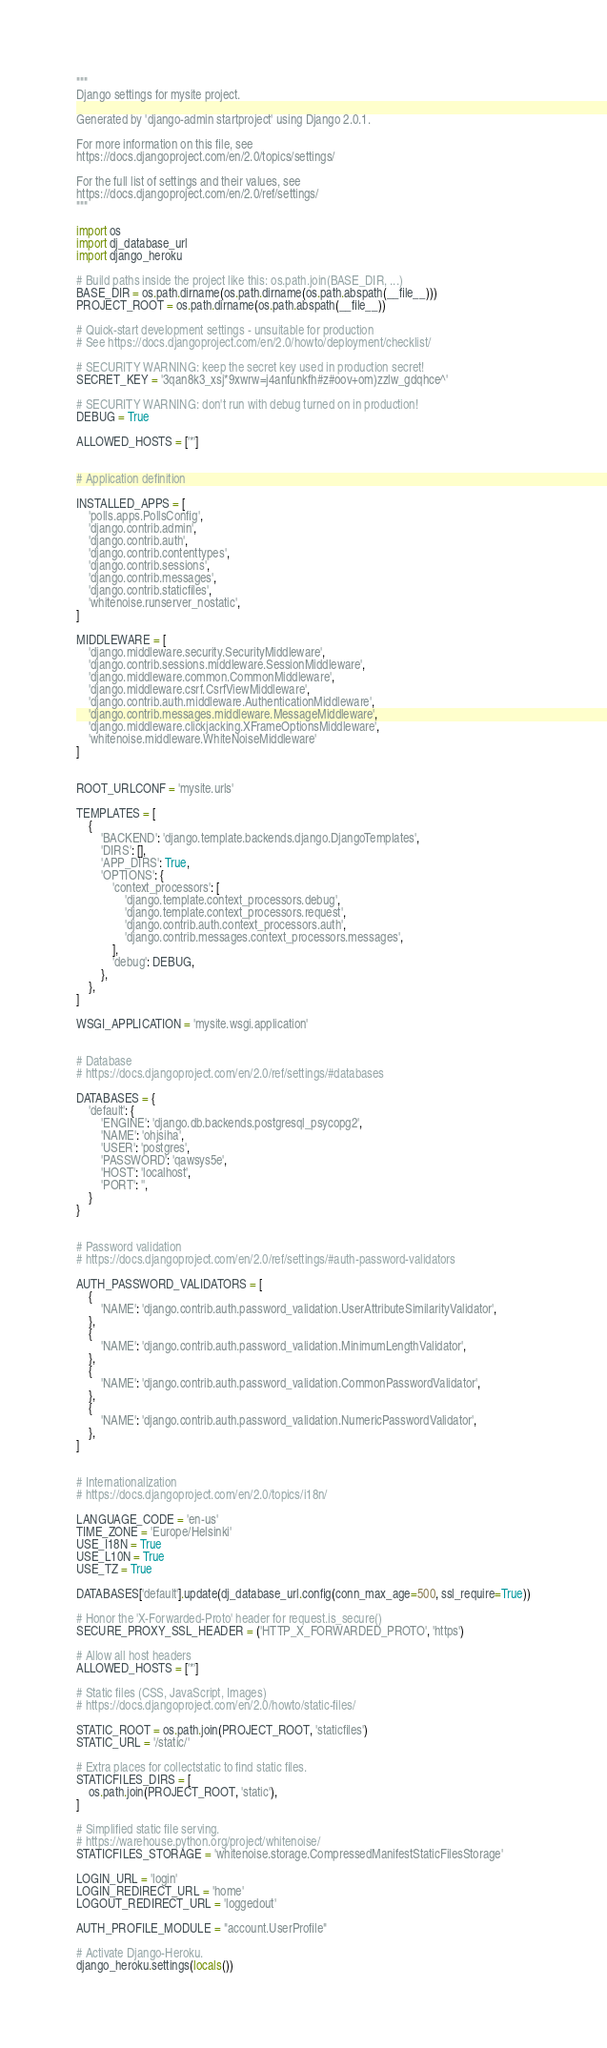Convert code to text. <code><loc_0><loc_0><loc_500><loc_500><_Python_>"""
Django settings for mysite project.

Generated by 'django-admin startproject' using Django 2.0.1.

For more information on this file, see
https://docs.djangoproject.com/en/2.0/topics/settings/

For the full list of settings and their values, see
https://docs.djangoproject.com/en/2.0/ref/settings/
"""

import os
import dj_database_url
import django_heroku

# Build paths inside the project like this: os.path.join(BASE_DIR, ...)
BASE_DIR = os.path.dirname(os.path.dirname(os.path.abspath(__file__)))
PROJECT_ROOT = os.path.dirname(os.path.abspath(__file__))

# Quick-start development settings - unsuitable for production
# See https://docs.djangoproject.com/en/2.0/howto/deployment/checklist/

# SECURITY WARNING: keep the secret key used in production secret!
SECRET_KEY = '3qan8k3_xsj*9xwrw=j4anfunkfh#z#oov+om)zzlw_gdqhce^'

# SECURITY WARNING: don't run with debug turned on in production!
DEBUG = True

ALLOWED_HOSTS = ['*']


# Application definition

INSTALLED_APPS = [
	'polls.apps.PollsConfig',
    'django.contrib.admin',
    'django.contrib.auth',
    'django.contrib.contenttypes',
    'django.contrib.sessions',
    'django.contrib.messages',
    'django.contrib.staticfiles',
	'whitenoise.runserver_nostatic',
]

MIDDLEWARE = [
    'django.middleware.security.SecurityMiddleware',
    'django.contrib.sessions.middleware.SessionMiddleware',
    'django.middleware.common.CommonMiddleware',
    'django.middleware.csrf.CsrfViewMiddleware',
    'django.contrib.auth.middleware.AuthenticationMiddleware',
    'django.contrib.messages.middleware.MessageMiddleware',
    'django.middleware.clickjacking.XFrameOptionsMiddleware',
	'whitenoise.middleware.WhiteNoiseMiddleware'
]


ROOT_URLCONF = 'mysite.urls'

TEMPLATES = [
    {
        'BACKEND': 'django.template.backends.django.DjangoTemplates',
        'DIRS': [],
        'APP_DIRS': True,
        'OPTIONS': {
            'context_processors': [
                'django.template.context_processors.debug',
                'django.template.context_processors.request',
                'django.contrib.auth.context_processors.auth',
                'django.contrib.messages.context_processors.messages',
            ],
			'debug': DEBUG,
        },
    },
]

WSGI_APPLICATION = 'mysite.wsgi.application'


# Database
# https://docs.djangoproject.com/en/2.0/ref/settings/#databases

DATABASES = {
    'default': {
        'ENGINE': 'django.db.backends.postgresql_psycopg2',
        'NAME': 'ohjsiha',
		'USER': 'postgres',
		'PASSWORD': 'qawsys5e',
		'HOST': 'localhost',
		'PORT': '',
    }
}


# Password validation
# https://docs.djangoproject.com/en/2.0/ref/settings/#auth-password-validators

AUTH_PASSWORD_VALIDATORS = [
    {
        'NAME': 'django.contrib.auth.password_validation.UserAttributeSimilarityValidator',
    },
    {
        'NAME': 'django.contrib.auth.password_validation.MinimumLengthValidator',
    },
    {
        'NAME': 'django.contrib.auth.password_validation.CommonPasswordValidator',
    },
    {
        'NAME': 'django.contrib.auth.password_validation.NumericPasswordValidator',
    },
]


# Internationalization
# https://docs.djangoproject.com/en/2.0/topics/i18n/

LANGUAGE_CODE = 'en-us'
TIME_ZONE = 'Europe/Helsinki'
USE_I18N = True
USE_L10N = True
USE_TZ = True

DATABASES['default'].update(dj_database_url.config(conn_max_age=500, ssl_require=True))

# Honor the 'X-Forwarded-Proto' header for request.is_secure()
SECURE_PROXY_SSL_HEADER = ('HTTP_X_FORWARDED_PROTO', 'https')

# Allow all host headers
ALLOWED_HOSTS = ['*']

# Static files (CSS, JavaScript, Images)
# https://docs.djangoproject.com/en/2.0/howto/static-files/

STATIC_ROOT = os.path.join(PROJECT_ROOT, 'staticfiles')
STATIC_URL = '/static/'

# Extra places for collectstatic to find static files.
STATICFILES_DIRS = [
    os.path.join(PROJECT_ROOT, 'static'),
]

# Simplified static file serving.
# https://warehouse.python.org/project/whitenoise/
STATICFILES_STORAGE = 'whitenoise.storage.CompressedManifestStaticFilesStorage'

LOGIN_URL = 'login'
LOGIN_REDIRECT_URL = 'home'
LOGOUT_REDIRECT_URL = 'loggedout'

AUTH_PROFILE_MODULE = "account.UserProfile"

# Activate Django-Heroku.
django_heroku.settings(locals())
</code> 